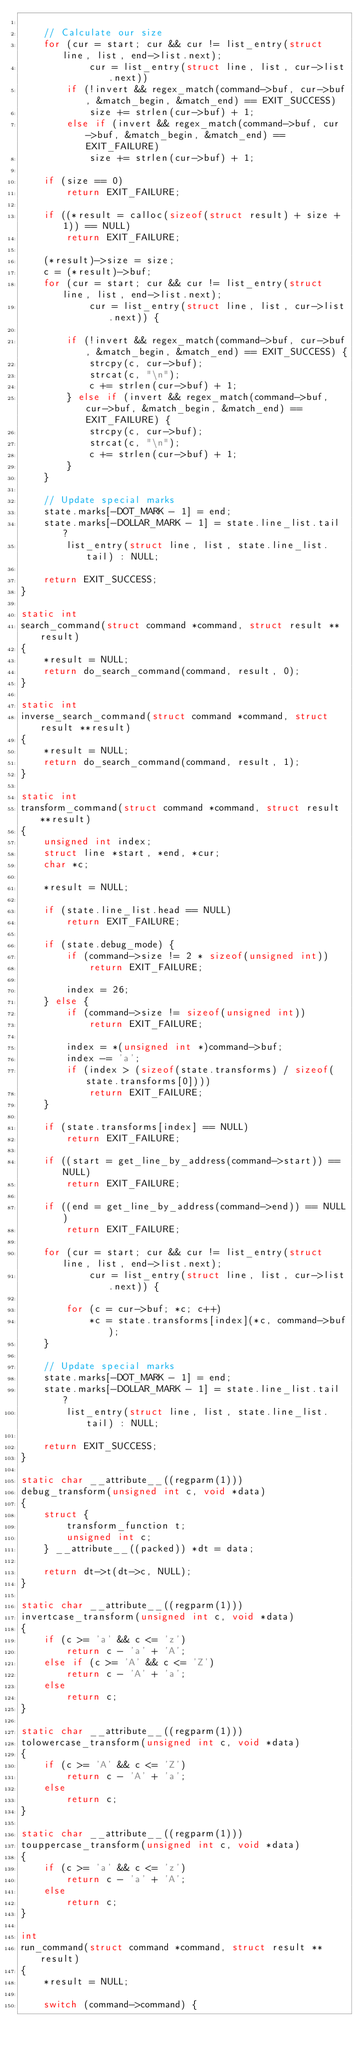Convert code to text. <code><loc_0><loc_0><loc_500><loc_500><_C_>
    // Calculate our size
    for (cur = start; cur && cur != list_entry(struct line, list, end->list.next);
            cur = list_entry(struct line, list, cur->list.next))
        if (!invert && regex_match(command->buf, cur->buf, &match_begin, &match_end) == EXIT_SUCCESS)
            size += strlen(cur->buf) + 1;
        else if (invert && regex_match(command->buf, cur->buf, &match_begin, &match_end) == EXIT_FAILURE)
            size += strlen(cur->buf) + 1;

    if (size == 0)
        return EXIT_FAILURE;

    if ((*result = calloc(sizeof(struct result) + size + 1)) == NULL)
        return EXIT_FAILURE;

    (*result)->size = size;
    c = (*result)->buf;
    for (cur = start; cur && cur != list_entry(struct line, list, end->list.next);
            cur = list_entry(struct line, list, cur->list.next)) {

        if (!invert && regex_match(command->buf, cur->buf, &match_begin, &match_end) == EXIT_SUCCESS) {
            strcpy(c, cur->buf);
            strcat(c, "\n");
            c += strlen(cur->buf) + 1;
        } else if (invert && regex_match(command->buf, cur->buf, &match_begin, &match_end) == EXIT_FAILURE) {
            strcpy(c, cur->buf);
            strcat(c, "\n");
            c += strlen(cur->buf) + 1;
        }
    }

    // Update special marks
    state.marks[-DOT_MARK - 1] = end;
    state.marks[-DOLLAR_MARK - 1] = state.line_list.tail ?
        list_entry(struct line, list, state.line_list.tail) : NULL;

    return EXIT_SUCCESS;
}

static int
search_command(struct command *command, struct result **result)
{
    *result = NULL;
    return do_search_command(command, result, 0);
}

static int
inverse_search_command(struct command *command, struct result **result)
{
    *result = NULL;
    return do_search_command(command, result, 1);
}

static int
transform_command(struct command *command, struct result **result)
{
    unsigned int index;
    struct line *start, *end, *cur;
    char *c;

    *result = NULL;

    if (state.line_list.head == NULL)
        return EXIT_FAILURE;

    if (state.debug_mode) {
        if (command->size != 2 * sizeof(unsigned int))
            return EXIT_FAILURE;

        index = 26;
    } else {
        if (command->size != sizeof(unsigned int))
            return EXIT_FAILURE;

        index = *(unsigned int *)command->buf;
        index -= 'a';
        if (index > (sizeof(state.transforms) / sizeof(state.transforms[0])))
            return EXIT_FAILURE;
    }

    if (state.transforms[index] == NULL)
        return EXIT_FAILURE;

    if ((start = get_line_by_address(command->start)) == NULL)
        return EXIT_FAILURE;

    if ((end = get_line_by_address(command->end)) == NULL)
        return EXIT_FAILURE;

    for (cur = start; cur && cur != list_entry(struct line, list, end->list.next);
            cur = list_entry(struct line, list, cur->list.next)) {

        for (c = cur->buf; *c; c++)
            *c = state.transforms[index](*c, command->buf);
    }

    // Update special marks
    state.marks[-DOT_MARK - 1] = end;
    state.marks[-DOLLAR_MARK - 1] = state.line_list.tail ?
        list_entry(struct line, list, state.line_list.tail) : NULL;

    return EXIT_SUCCESS;
}

static char __attribute__((regparm(1)))
debug_transform(unsigned int c, void *data)
{
    struct {
        transform_function t;
        unsigned int c;
    } __attribute__((packed)) *dt = data;

    return dt->t(dt->c, NULL);
}

static char __attribute__((regparm(1)))
invertcase_transform(unsigned int c, void *data)
{
    if (c >= 'a' && c <= 'z')
        return c - 'a' + 'A';
    else if (c >= 'A' && c <= 'Z')
        return c - 'A' + 'a';
    else
        return c;
}

static char __attribute__((regparm(1)))
tolowercase_transform(unsigned int c, void *data)
{
    if (c >= 'A' && c <= 'Z')
        return c - 'A' + 'a';
    else
        return c;
}

static char __attribute__((regparm(1)))
touppercase_transform(unsigned int c, void *data)
{
    if (c >= 'a' && c <= 'z')
        return c - 'a' + 'A';
    else
        return c;
}

int
run_command(struct command *command, struct result **result)
{
    *result = NULL;

    switch (command->command) {</code> 